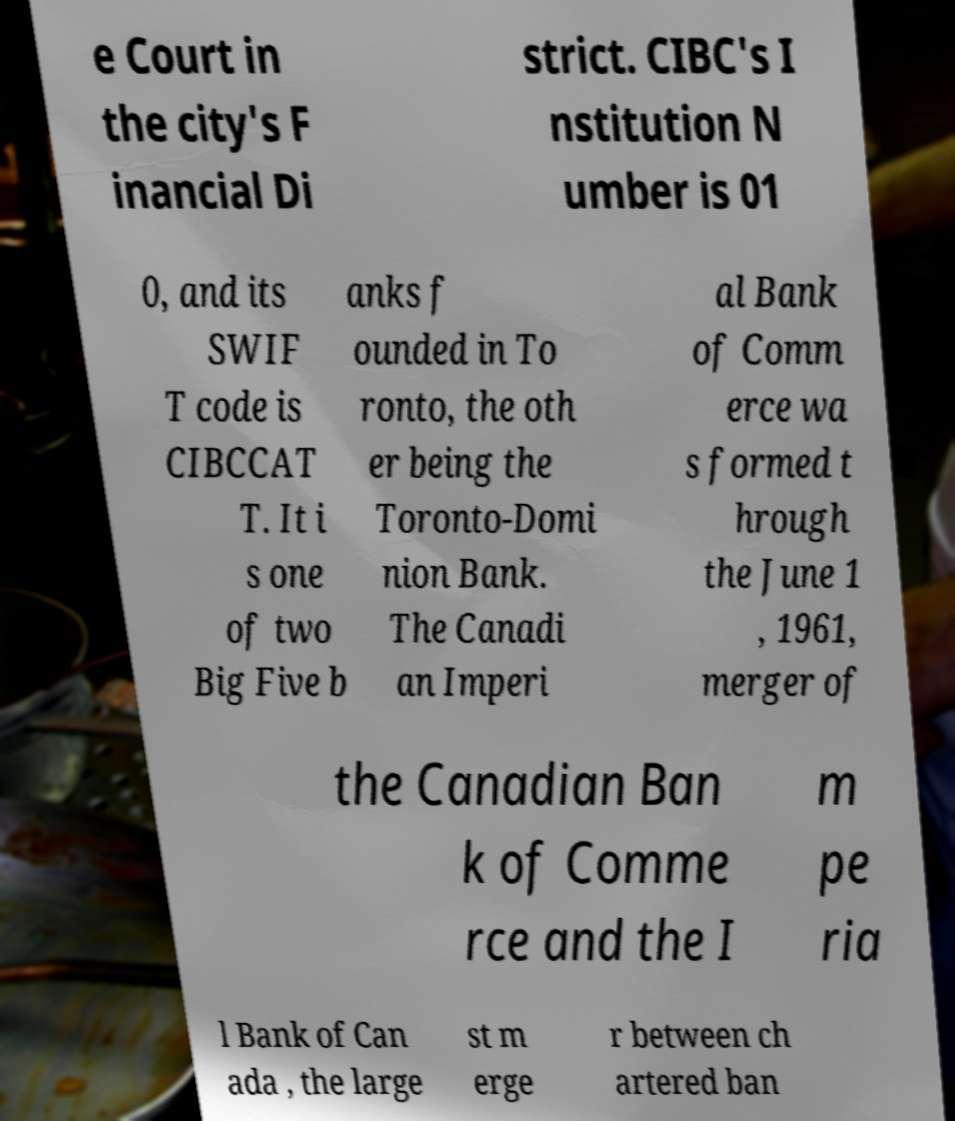Please identify and transcribe the text found in this image. e Court in the city's F inancial Di strict. CIBC's I nstitution N umber is 01 0, and its SWIF T code is CIBCCAT T. It i s one of two Big Five b anks f ounded in To ronto, the oth er being the Toronto-Domi nion Bank. The Canadi an Imperi al Bank of Comm erce wa s formed t hrough the June 1 , 1961, merger of the Canadian Ban k of Comme rce and the I m pe ria l Bank of Can ada , the large st m erge r between ch artered ban 